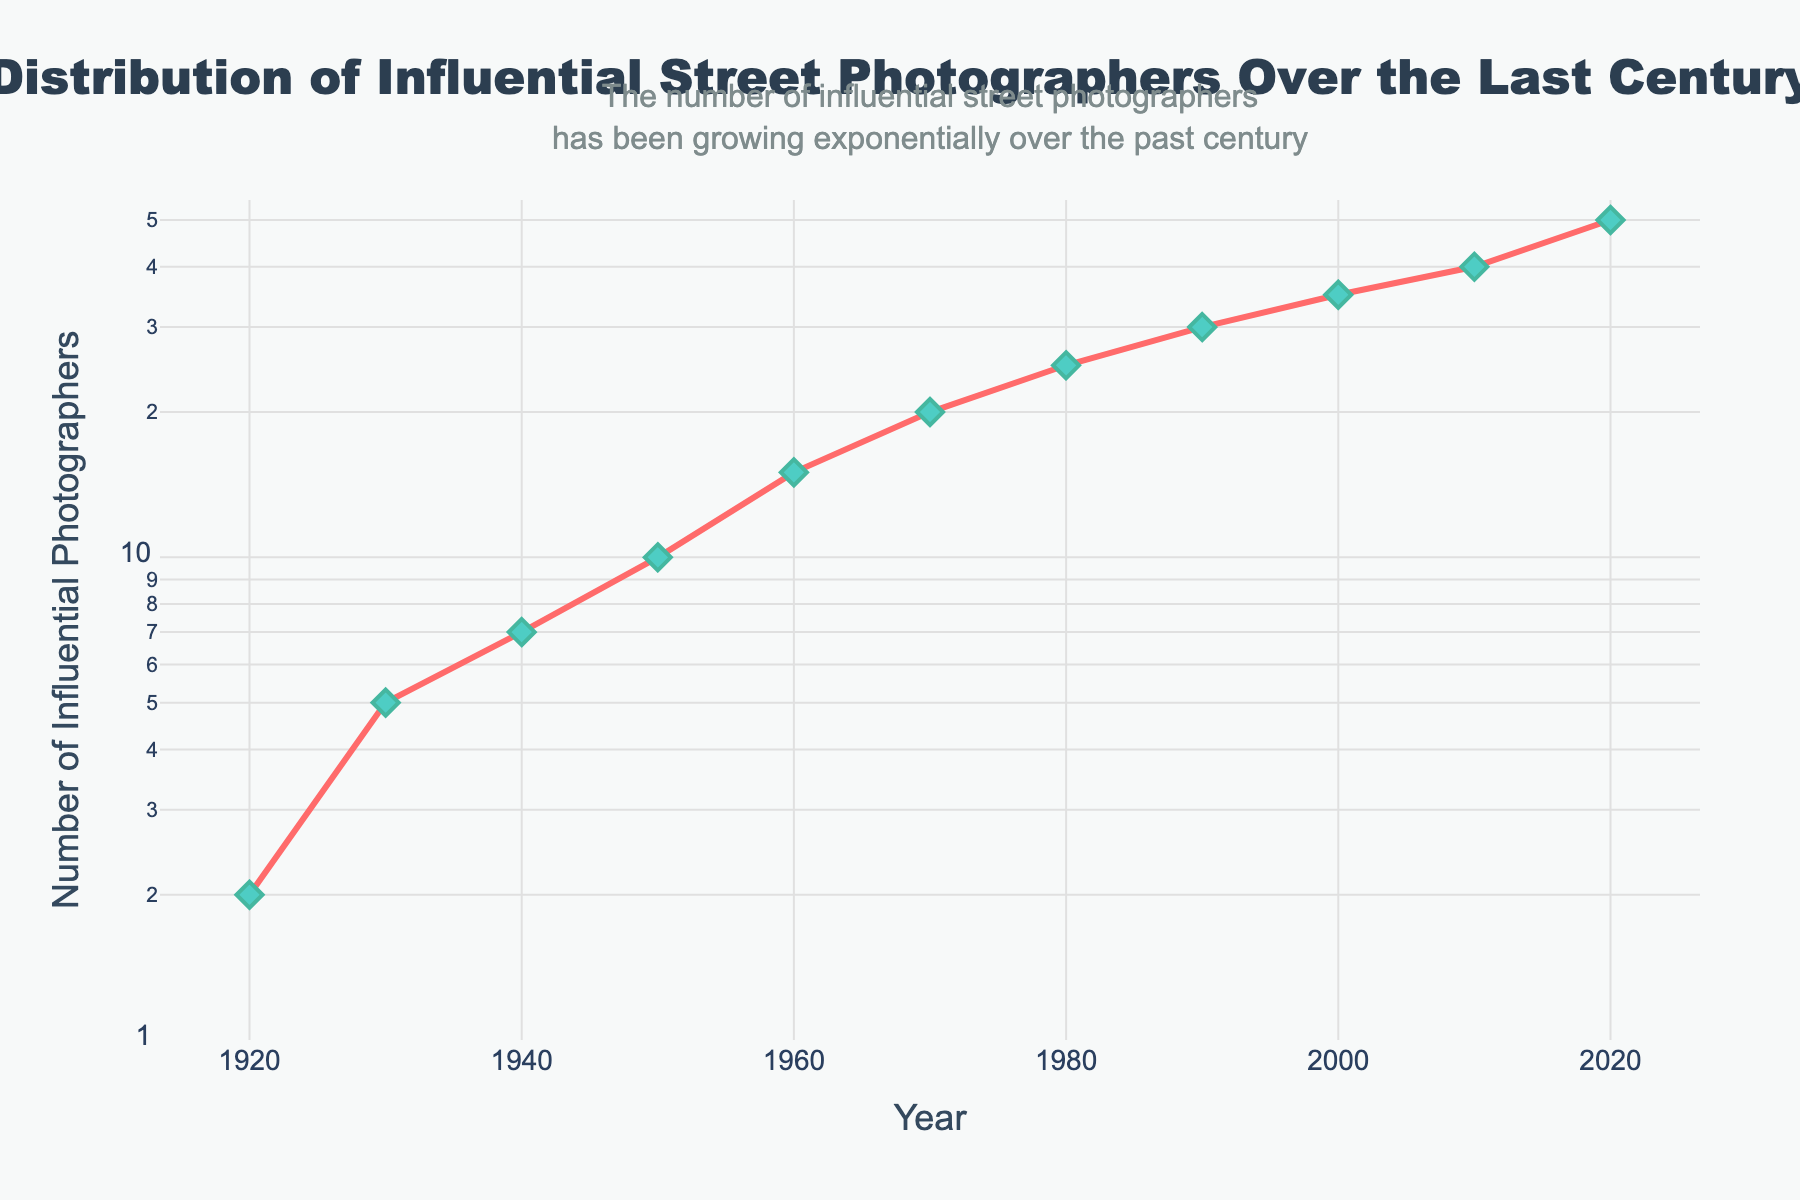What is the title of the figure? The title of the figure is located at the top and is in bold and large font. It reads "Distribution of Influential Street Photographers Over the Last Century".
Answer: Distribution of Influential Street Photographers Over the Last Century What is the y-axis titled? The y-axis title can be found at the left side of the plot. It reads "Number of Influential Photographers".
Answer: Number of Influential Photographers How many influential street photographers were there in the year 1950? To determine the count in 1950, look for the marker on the plot corresponding to the year 1950 on the x-axis. The count is 10.
Answer: 10 Between which consecutive decades did the number of influential street photographers see the largest increase? To find this, compare the increase in numbers between each consecutive pair of decades. The largest increase is from 2010 (40 photographers) to 2020 (50 photographers), an increase of 10.
Answer: 2010 to 2020 What trend can be observed in the number of influential street photographers over the past century? Examine the overall pattern of the plot. The number of influential street photographers has been growing exponentially over the past century, as indicated by the upward curve on the log scale y-axis.
Answer: Exponential growth How does the increase in photographer count from 1940 to 1950 compare to the increase from 2000 to 2010? From 1940 (7) to 1950 (10), the increase is 10 - 7 = 3. From 2000 (35) to 2010 (40), the increase is 40 - 35 = 5. Comparing these, the increase from 2000 to 2010 is larger.
Answer: 2000 to 2010 is larger What is the approximate number of influential street photographers in the year 1930? Locate the point on the plot that corresponds to the year 1930. The plot shows that there were approximately 5 influential photographers in 1930.
Answer: 5 Is the growth of influential street photographers linear or exponential when considered on a regular (non-logarithmic) scale? The plot uses a log scale for the y-axis, and on a log scale, a straight line indicates exponential growth. Thus, the growth is exponential rather than linear.
Answer: Exponential How does the log scale affect the appearance of the data trend in the plot? A log scale compresses the differences between large values while highlighting changes among smaller values. The exponential growth trend appears as a relative straight line in this log-scale plot.
Answer: Compresses large values' differences When did the count of influential street photographers first exceed 20? Look for the year when the data point first crosses above the value of 20 on the y-axis. The data shows it occurred in the 1970s.
Answer: 1970 